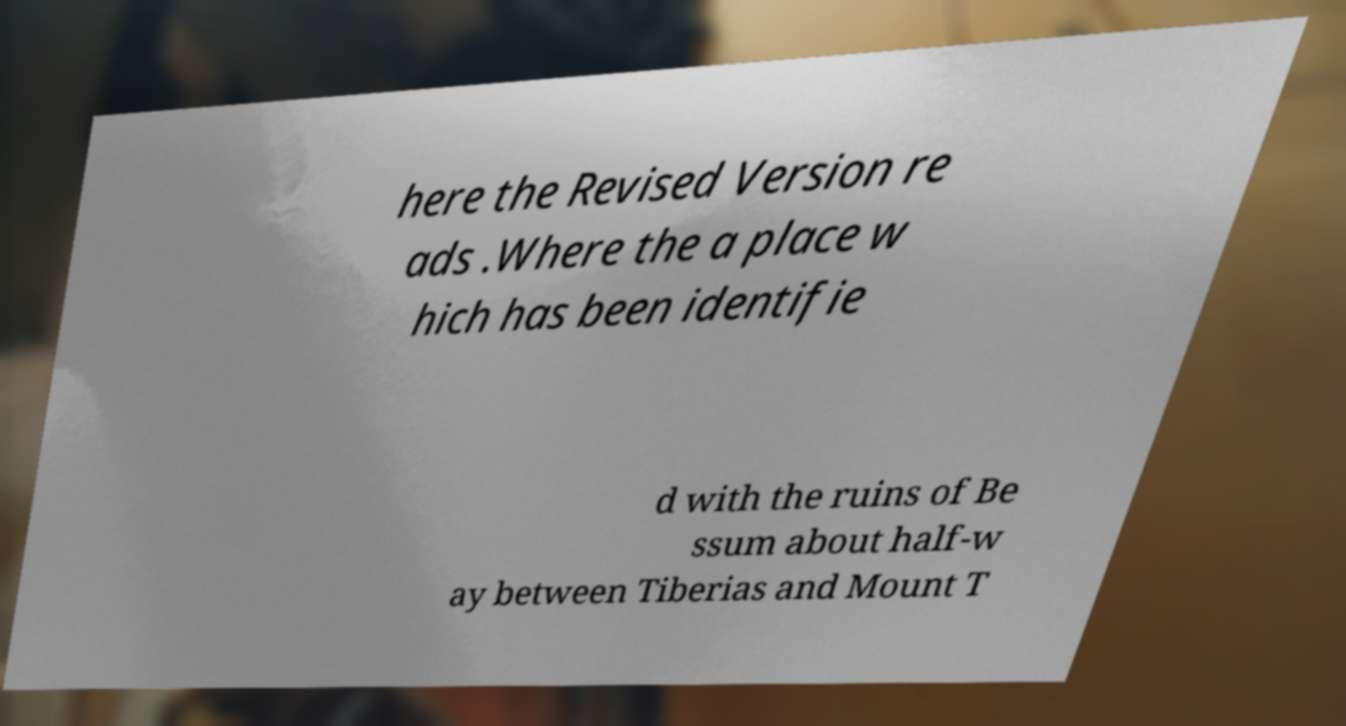What messages or text are displayed in this image? I need them in a readable, typed format. here the Revised Version re ads .Where the a place w hich has been identifie d with the ruins of Be ssum about half-w ay between Tiberias and Mount T 